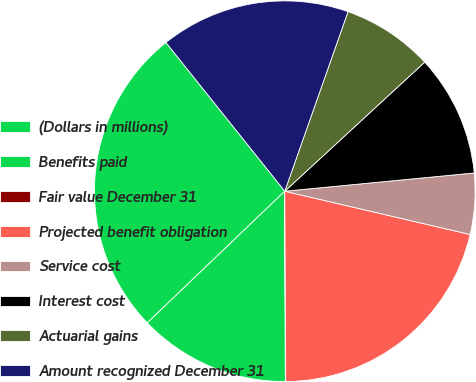<chart> <loc_0><loc_0><loc_500><loc_500><pie_chart><fcel>(Dollars in millions)<fcel>Benefits paid<fcel>Fair value December 31<fcel>Projected benefit obligation<fcel>Service cost<fcel>Interest cost<fcel>Actuarial gains<fcel>Amount recognized December 31<nl><fcel>26.42%<fcel>12.9%<fcel>0.03%<fcel>21.27%<fcel>5.18%<fcel>10.33%<fcel>7.75%<fcel>16.12%<nl></chart> 